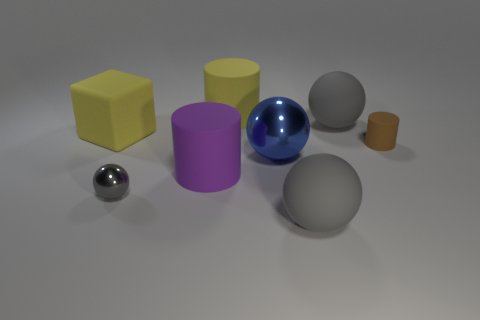How many gray spheres must be subtracted to get 1 gray spheres? 2 Add 1 large cyan metallic blocks. How many objects exist? 9 Subtract all large spheres. How many spheres are left? 1 Subtract all blue spheres. How many spheres are left? 3 Subtract all blocks. How many objects are left? 7 Subtract 1 blocks. How many blocks are left? 0 Subtract all brown cylinders. How many gray spheres are left? 3 Subtract all tiny brown things. Subtract all small gray matte cylinders. How many objects are left? 7 Add 7 small metallic objects. How many small metallic objects are left? 8 Add 1 big brown balls. How many big brown balls exist? 1 